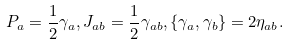Convert formula to latex. <formula><loc_0><loc_0><loc_500><loc_500>P _ { a } = \frac { 1 } { 2 } \gamma _ { a } , J _ { a b } = \frac { 1 } { 2 } \gamma _ { a b } , \{ \gamma _ { a } , \gamma _ { b } \} = 2 \eta _ { a b } .</formula> 